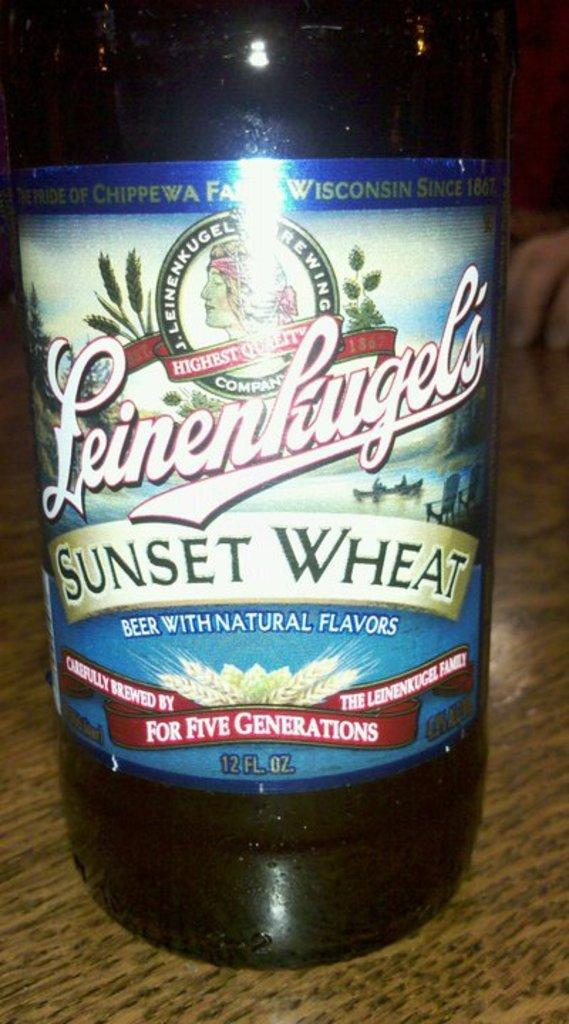<image>
Relay a brief, clear account of the picture shown. a bottle of wisconsin leinenkugel sunset wheat beer 